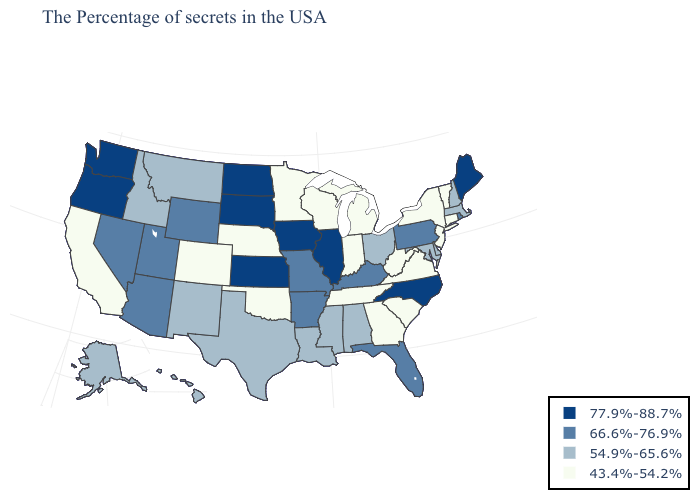Name the states that have a value in the range 43.4%-54.2%?
Keep it brief. Vermont, Connecticut, New York, New Jersey, Virginia, South Carolina, West Virginia, Georgia, Michigan, Indiana, Tennessee, Wisconsin, Minnesota, Nebraska, Oklahoma, Colorado, California. What is the value of Oklahoma?
Keep it brief. 43.4%-54.2%. What is the highest value in the MidWest ?
Write a very short answer. 77.9%-88.7%. What is the highest value in the South ?
Quick response, please. 77.9%-88.7%. What is the value of Oregon?
Keep it brief. 77.9%-88.7%. What is the value of Vermont?
Quick response, please. 43.4%-54.2%. Does Wisconsin have the same value as Montana?
Short answer required. No. What is the highest value in states that border New Jersey?
Keep it brief. 66.6%-76.9%. Among the states that border Idaho , which have the highest value?
Concise answer only. Washington, Oregon. Does Tennessee have the same value as Wyoming?
Quick response, please. No. Name the states that have a value in the range 77.9%-88.7%?
Quick response, please. Maine, North Carolina, Illinois, Iowa, Kansas, South Dakota, North Dakota, Washington, Oregon. Does Iowa have a higher value than Illinois?
Write a very short answer. No. Which states hav the highest value in the MidWest?
Short answer required. Illinois, Iowa, Kansas, South Dakota, North Dakota. Name the states that have a value in the range 43.4%-54.2%?
Give a very brief answer. Vermont, Connecticut, New York, New Jersey, Virginia, South Carolina, West Virginia, Georgia, Michigan, Indiana, Tennessee, Wisconsin, Minnesota, Nebraska, Oklahoma, Colorado, California. What is the highest value in the USA?
Keep it brief. 77.9%-88.7%. 